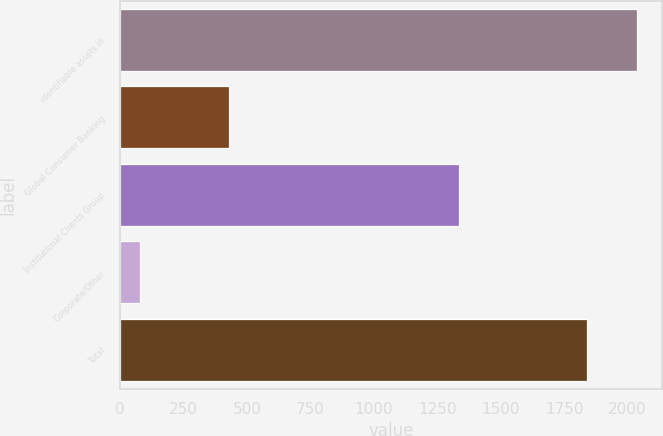<chart> <loc_0><loc_0><loc_500><loc_500><bar_chart><fcel>identifiable assets in<fcel>Global Consumer Banking<fcel>Institutional Clients Group<fcel>Corporate/Other<fcel>Total<nl><fcel>2035.9<fcel>428<fcel>1336<fcel>78<fcel>1842<nl></chart> 